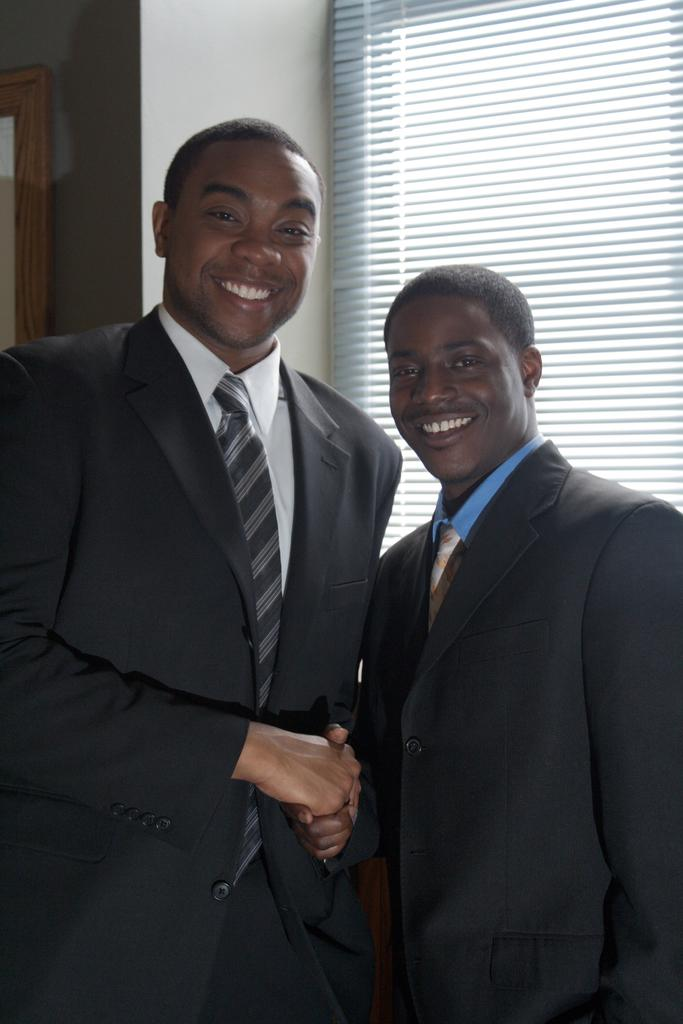How many people are in the image? There are two people in the image. What are the people doing in the image? The people are smiling and shaking hands. What can be seen in the background of the image? There is a wall and a window in the background of the image. What type of field is visible through the window in the image? There is no field visible through the window in the image; only a wall and a window are present in the background. 